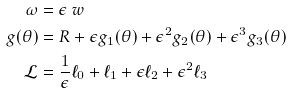Convert formula to latex. <formula><loc_0><loc_0><loc_500><loc_500>\omega & = \epsilon \ w \\ g ( \theta ) & = R + \epsilon g _ { 1 } ( \theta ) + \epsilon ^ { 2 } g _ { 2 } ( \theta ) + \epsilon ^ { 3 } g _ { 3 } ( \theta ) \\ \mathcal { L } & = \frac { 1 } { \epsilon } \ell _ { 0 } + \ell _ { 1 } + \epsilon \ell _ { 2 } + \epsilon ^ { 2 } \ell _ { 3 }</formula> 